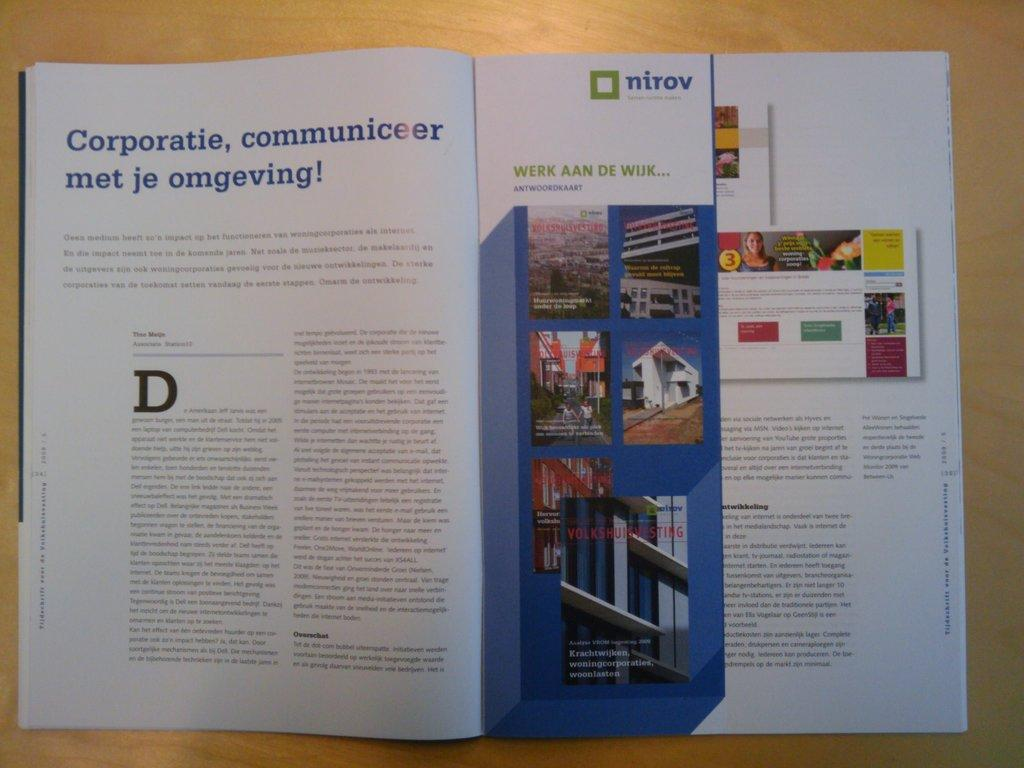<image>
Share a concise interpretation of the image provided. a book that is open and says corporatie communiceer 